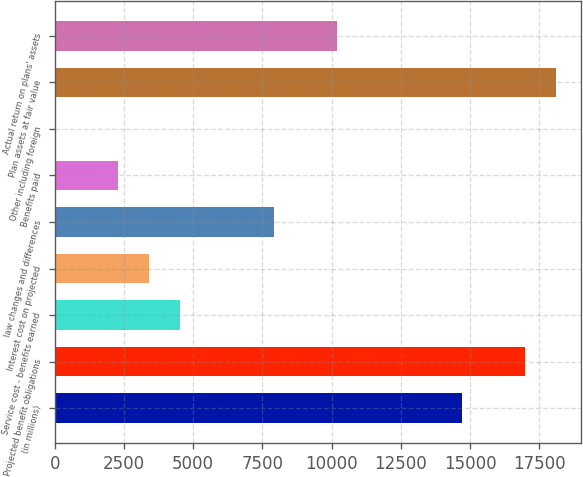Convert chart to OTSL. <chart><loc_0><loc_0><loc_500><loc_500><bar_chart><fcel>(in millions)<fcel>Projected benefit obligations<fcel>Service cost - benefits earned<fcel>Interest cost on projected<fcel>law changes and differences<fcel>Benefits paid<fcel>Other including foreign<fcel>Plan assets at fair value<fcel>Actual return on plans' assets<nl><fcel>14712.6<fcel>16973<fcel>4540.8<fcel>3410.6<fcel>7931.4<fcel>2280.4<fcel>20<fcel>18103.2<fcel>10191.8<nl></chart> 